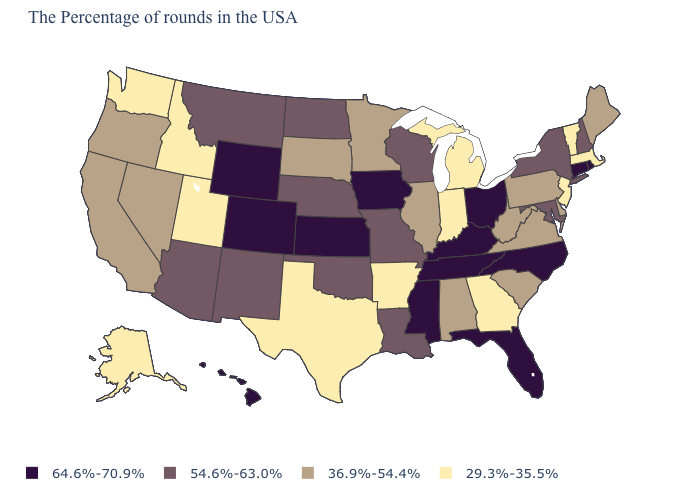Does Mississippi have the same value as Oklahoma?
Concise answer only. No. Does the first symbol in the legend represent the smallest category?
Short answer required. No. How many symbols are there in the legend?
Write a very short answer. 4. What is the value of Arizona?
Answer briefly. 54.6%-63.0%. How many symbols are there in the legend?
Answer briefly. 4. Which states have the lowest value in the USA?
Give a very brief answer. Massachusetts, Vermont, New Jersey, Georgia, Michigan, Indiana, Arkansas, Texas, Utah, Idaho, Washington, Alaska. What is the value of Rhode Island?
Write a very short answer. 64.6%-70.9%. Name the states that have a value in the range 64.6%-70.9%?
Quick response, please. Rhode Island, Connecticut, North Carolina, Ohio, Florida, Kentucky, Tennessee, Mississippi, Iowa, Kansas, Wyoming, Colorado, Hawaii. What is the value of Idaho?
Concise answer only. 29.3%-35.5%. What is the value of North Carolina?
Keep it brief. 64.6%-70.9%. What is the value of Arkansas?
Give a very brief answer. 29.3%-35.5%. Which states have the highest value in the USA?
Keep it brief. Rhode Island, Connecticut, North Carolina, Ohio, Florida, Kentucky, Tennessee, Mississippi, Iowa, Kansas, Wyoming, Colorado, Hawaii. Does Massachusetts have the lowest value in the Northeast?
Answer briefly. Yes. Does the first symbol in the legend represent the smallest category?
Be succinct. No. What is the value of Texas?
Be succinct. 29.3%-35.5%. 